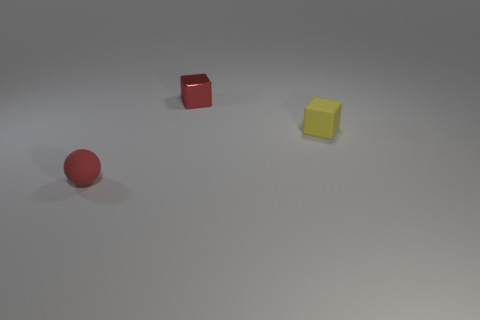Add 2 big yellow metallic things. How many objects exist? 5 Subtract all red cubes. How many cubes are left? 1 Subtract all cubes. How many objects are left? 1 Subtract all green cubes. Subtract all red spheres. How many cubes are left? 2 Add 1 tiny metal things. How many tiny metal things are left? 2 Add 3 cyan rubber cylinders. How many cyan rubber cylinders exist? 3 Subtract 0 brown cylinders. How many objects are left? 3 Subtract all tiny red balls. Subtract all red cubes. How many objects are left? 1 